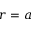<formula> <loc_0><loc_0><loc_500><loc_500>r = a</formula> 